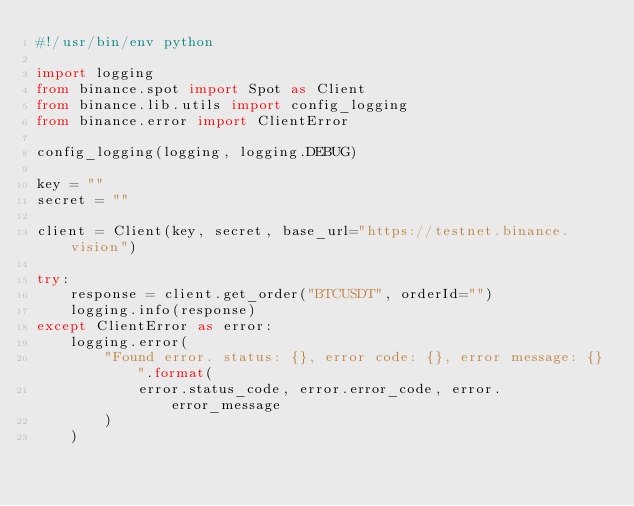Convert code to text. <code><loc_0><loc_0><loc_500><loc_500><_Python_>#!/usr/bin/env python

import logging
from binance.spot import Spot as Client
from binance.lib.utils import config_logging
from binance.error import ClientError

config_logging(logging, logging.DEBUG)

key = ""
secret = ""

client = Client(key, secret, base_url="https://testnet.binance.vision")

try:
    response = client.get_order("BTCUSDT", orderId="")
    logging.info(response)
except ClientError as error:
    logging.error(
        "Found error. status: {}, error code: {}, error message: {}".format(
            error.status_code, error.error_code, error.error_message
        )
    )
</code> 